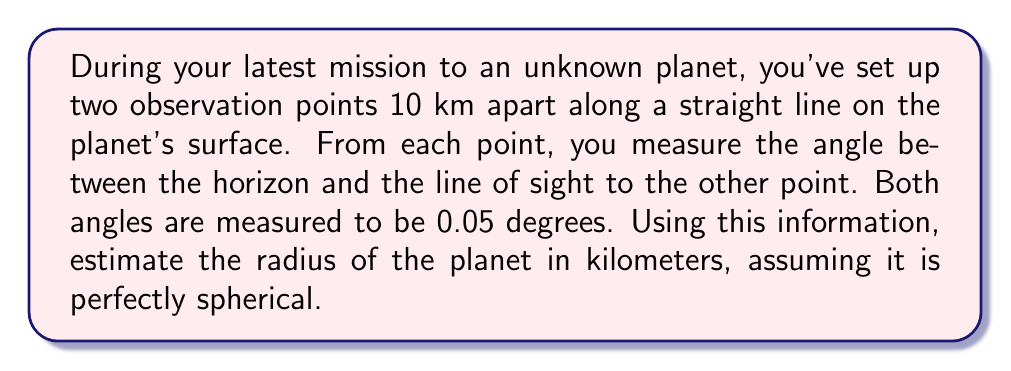Give your solution to this math problem. Let's approach this step-by-step:

1) First, let's visualize the problem:

[asy]
import geometry;

pair A = (0,0), B = (10,0), C = (5,-100);
draw(A--B--C--A);
draw(A--(0,-120), dashed);
draw(B--(10,-120), dashed);

label("A", A, N);
label("B", B, N);
label("C (planet center)", C, S);

real ang = 0.05 * pi / 180;
draw(arc(A, 1, -90, -90+ang), Arrow);
draw(arc(B, 1, -90-ang, -90), Arrow);

label("10 km", (A--B), N);
label("R", (A--C), W);
label("R", (B--C), E);
label("0.05°", (0.5,0.5), NE);
label("0.05°", (9.5,0.5), NW);
[/asy]

2) Let R be the radius of the planet. We have a right-angled triangle where:
   - The hypotenuse is R
   - Half of the distance between observation points is 5 km
   - The angle at the center is 0.05°

3) We can use the formula: $\cos(\theta) = \frac{\text{adjacent}}{\text{hypotenuse}}$

4) In our case: $\cos(0.05°) = \frac{R}{R+5}$

5) Rearranging this equation:
   $$R = \frac{5}{\frac{1}{\cos(0.05°)} - 1}$$

6) Now let's calculate:
   $\cos(0.05°) \approx 0.999999619$
   
   $$R = \frac{5}{\frac{1}{0.999999619} - 1} \approx 11459.16 \text{ km}$$

7) Rounding to the nearest whole number: 11,459 km
Answer: 11,459 km 